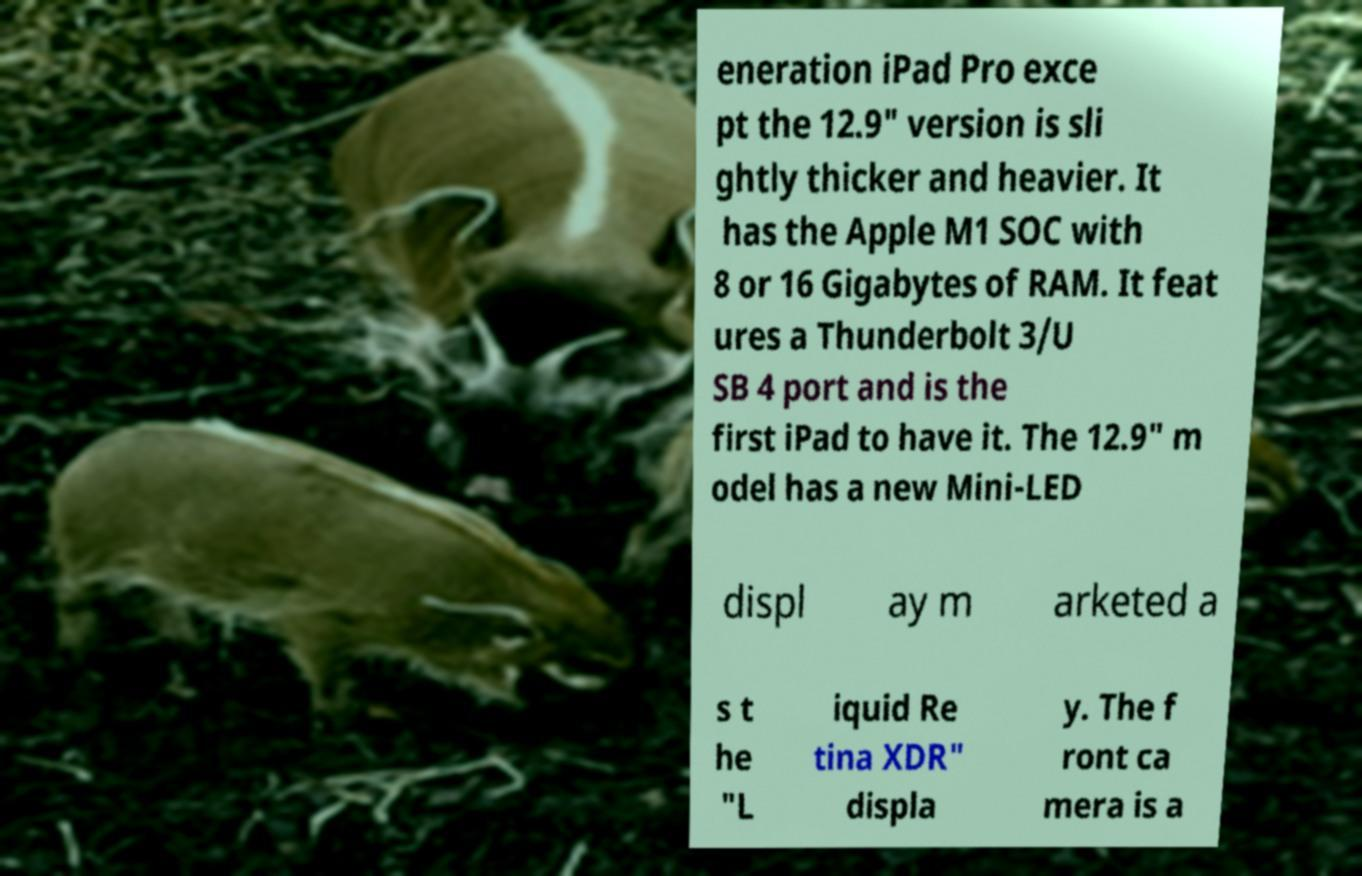For documentation purposes, I need the text within this image transcribed. Could you provide that? eneration iPad Pro exce pt the 12.9" version is sli ghtly thicker and heavier. It has the Apple M1 SOC with 8 or 16 Gigabytes of RAM. It feat ures a Thunderbolt 3/U SB 4 port and is the first iPad to have it. The 12.9" m odel has a new Mini-LED displ ay m arketed a s t he "L iquid Re tina XDR" displa y. The f ront ca mera is a 